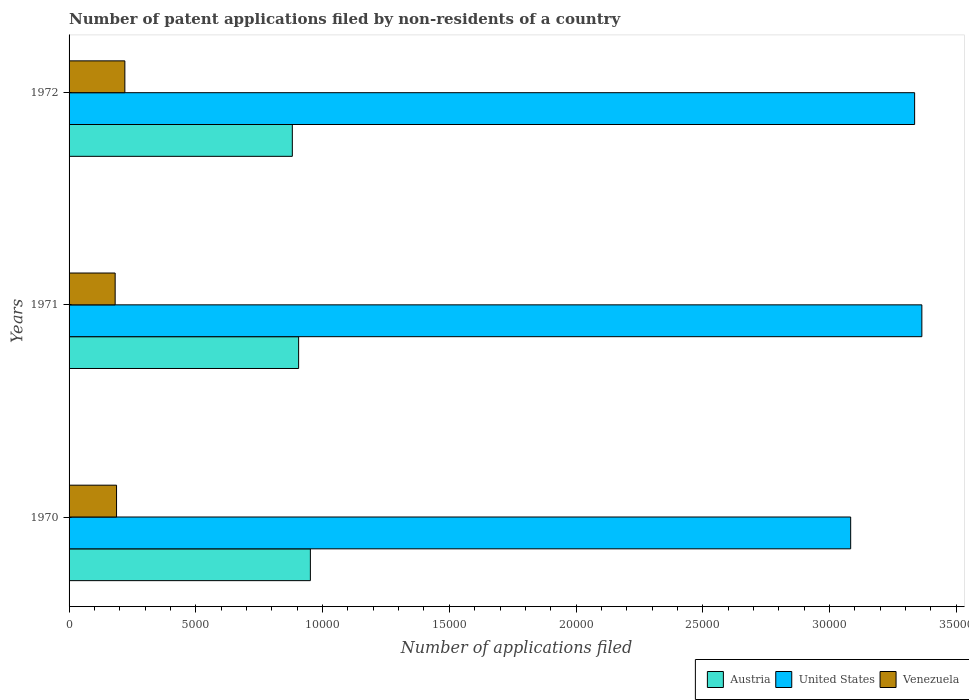How many different coloured bars are there?
Offer a very short reply. 3. How many bars are there on the 2nd tick from the top?
Provide a succinct answer. 3. How many bars are there on the 3rd tick from the bottom?
Make the answer very short. 3. What is the label of the 2nd group of bars from the top?
Make the answer very short. 1971. What is the number of applications filed in Austria in 1970?
Give a very brief answer. 9519. Across all years, what is the maximum number of applications filed in Venezuela?
Offer a terse response. 2201. Across all years, what is the minimum number of applications filed in Austria?
Offer a terse response. 8807. What is the total number of applications filed in Austria in the graph?
Offer a terse response. 2.74e+04. What is the difference between the number of applications filed in Austria in 1970 and that in 1972?
Offer a terse response. 712. What is the difference between the number of applications filed in United States in 1970 and the number of applications filed in Venezuela in 1971?
Make the answer very short. 2.90e+04. What is the average number of applications filed in Venezuela per year?
Your answer should be very brief. 1964. In the year 1971, what is the difference between the number of applications filed in Austria and number of applications filed in United States?
Make the answer very short. -2.46e+04. In how many years, is the number of applications filed in United States greater than 4000 ?
Provide a short and direct response. 3. What is the ratio of the number of applications filed in United States in 1971 to that in 1972?
Your response must be concise. 1.01. Is the number of applications filed in United States in 1971 less than that in 1972?
Offer a very short reply. No. Is the difference between the number of applications filed in Austria in 1970 and 1972 greater than the difference between the number of applications filed in United States in 1970 and 1972?
Provide a short and direct response. Yes. What is the difference between the highest and the second highest number of applications filed in Austria?
Your answer should be compact. 464. What is the difference between the highest and the lowest number of applications filed in Austria?
Offer a terse response. 712. What does the 2nd bar from the top in 1972 represents?
Your response must be concise. United States. What does the 3rd bar from the bottom in 1971 represents?
Provide a succinct answer. Venezuela. Is it the case that in every year, the sum of the number of applications filed in United States and number of applications filed in Austria is greater than the number of applications filed in Venezuela?
Offer a terse response. Yes. How many years are there in the graph?
Your answer should be compact. 3. Are the values on the major ticks of X-axis written in scientific E-notation?
Keep it short and to the point. No. How are the legend labels stacked?
Provide a succinct answer. Horizontal. What is the title of the graph?
Offer a terse response. Number of patent applications filed by non-residents of a country. Does "Malaysia" appear as one of the legend labels in the graph?
Provide a short and direct response. No. What is the label or title of the X-axis?
Ensure brevity in your answer.  Number of applications filed. What is the label or title of the Y-axis?
Your answer should be compact. Years. What is the Number of applications filed of Austria in 1970?
Offer a terse response. 9519. What is the Number of applications filed of United States in 1970?
Your answer should be compact. 3.08e+04. What is the Number of applications filed in Venezuela in 1970?
Your answer should be compact. 1873. What is the Number of applications filed of Austria in 1971?
Keep it short and to the point. 9055. What is the Number of applications filed of United States in 1971?
Your response must be concise. 3.36e+04. What is the Number of applications filed in Venezuela in 1971?
Your response must be concise. 1818. What is the Number of applications filed in Austria in 1972?
Keep it short and to the point. 8807. What is the Number of applications filed in United States in 1972?
Provide a succinct answer. 3.34e+04. What is the Number of applications filed of Venezuela in 1972?
Your answer should be very brief. 2201. Across all years, what is the maximum Number of applications filed in Austria?
Give a very brief answer. 9519. Across all years, what is the maximum Number of applications filed in United States?
Offer a very short reply. 3.36e+04. Across all years, what is the maximum Number of applications filed in Venezuela?
Provide a succinct answer. 2201. Across all years, what is the minimum Number of applications filed of Austria?
Offer a terse response. 8807. Across all years, what is the minimum Number of applications filed of United States?
Provide a short and direct response. 3.08e+04. Across all years, what is the minimum Number of applications filed in Venezuela?
Provide a succinct answer. 1818. What is the total Number of applications filed of Austria in the graph?
Your response must be concise. 2.74e+04. What is the total Number of applications filed of United States in the graph?
Keep it short and to the point. 9.78e+04. What is the total Number of applications filed in Venezuela in the graph?
Give a very brief answer. 5892. What is the difference between the Number of applications filed of Austria in 1970 and that in 1971?
Ensure brevity in your answer.  464. What is the difference between the Number of applications filed of United States in 1970 and that in 1971?
Ensure brevity in your answer.  -2808. What is the difference between the Number of applications filed in Venezuela in 1970 and that in 1971?
Your response must be concise. 55. What is the difference between the Number of applications filed in Austria in 1970 and that in 1972?
Provide a short and direct response. 712. What is the difference between the Number of applications filed in United States in 1970 and that in 1972?
Keep it short and to the point. -2523. What is the difference between the Number of applications filed of Venezuela in 1970 and that in 1972?
Your response must be concise. -328. What is the difference between the Number of applications filed in Austria in 1971 and that in 1972?
Your answer should be compact. 248. What is the difference between the Number of applications filed in United States in 1971 and that in 1972?
Provide a short and direct response. 285. What is the difference between the Number of applications filed in Venezuela in 1971 and that in 1972?
Give a very brief answer. -383. What is the difference between the Number of applications filed of Austria in 1970 and the Number of applications filed of United States in 1971?
Provide a short and direct response. -2.41e+04. What is the difference between the Number of applications filed in Austria in 1970 and the Number of applications filed in Venezuela in 1971?
Your answer should be very brief. 7701. What is the difference between the Number of applications filed in United States in 1970 and the Number of applications filed in Venezuela in 1971?
Your answer should be compact. 2.90e+04. What is the difference between the Number of applications filed of Austria in 1970 and the Number of applications filed of United States in 1972?
Provide a succinct answer. -2.38e+04. What is the difference between the Number of applications filed in Austria in 1970 and the Number of applications filed in Venezuela in 1972?
Ensure brevity in your answer.  7318. What is the difference between the Number of applications filed in United States in 1970 and the Number of applications filed in Venezuela in 1972?
Give a very brief answer. 2.86e+04. What is the difference between the Number of applications filed of Austria in 1971 and the Number of applications filed of United States in 1972?
Your answer should be compact. -2.43e+04. What is the difference between the Number of applications filed in Austria in 1971 and the Number of applications filed in Venezuela in 1972?
Ensure brevity in your answer.  6854. What is the difference between the Number of applications filed of United States in 1971 and the Number of applications filed of Venezuela in 1972?
Offer a very short reply. 3.14e+04. What is the average Number of applications filed of Austria per year?
Your answer should be very brief. 9127. What is the average Number of applications filed in United States per year?
Your response must be concise. 3.26e+04. What is the average Number of applications filed in Venezuela per year?
Offer a very short reply. 1964. In the year 1970, what is the difference between the Number of applications filed in Austria and Number of applications filed in United States?
Ensure brevity in your answer.  -2.13e+04. In the year 1970, what is the difference between the Number of applications filed in Austria and Number of applications filed in Venezuela?
Ensure brevity in your answer.  7646. In the year 1970, what is the difference between the Number of applications filed in United States and Number of applications filed in Venezuela?
Keep it short and to the point. 2.90e+04. In the year 1971, what is the difference between the Number of applications filed of Austria and Number of applications filed of United States?
Offer a terse response. -2.46e+04. In the year 1971, what is the difference between the Number of applications filed of Austria and Number of applications filed of Venezuela?
Make the answer very short. 7237. In the year 1971, what is the difference between the Number of applications filed of United States and Number of applications filed of Venezuela?
Provide a short and direct response. 3.18e+04. In the year 1972, what is the difference between the Number of applications filed of Austria and Number of applications filed of United States?
Your answer should be very brief. -2.45e+04. In the year 1972, what is the difference between the Number of applications filed of Austria and Number of applications filed of Venezuela?
Your response must be concise. 6606. In the year 1972, what is the difference between the Number of applications filed of United States and Number of applications filed of Venezuela?
Keep it short and to the point. 3.12e+04. What is the ratio of the Number of applications filed in Austria in 1970 to that in 1971?
Offer a terse response. 1.05. What is the ratio of the Number of applications filed in United States in 1970 to that in 1971?
Keep it short and to the point. 0.92. What is the ratio of the Number of applications filed of Venezuela in 1970 to that in 1971?
Make the answer very short. 1.03. What is the ratio of the Number of applications filed in Austria in 1970 to that in 1972?
Your answer should be compact. 1.08. What is the ratio of the Number of applications filed in United States in 1970 to that in 1972?
Ensure brevity in your answer.  0.92. What is the ratio of the Number of applications filed in Venezuela in 1970 to that in 1972?
Offer a terse response. 0.85. What is the ratio of the Number of applications filed of Austria in 1971 to that in 1972?
Give a very brief answer. 1.03. What is the ratio of the Number of applications filed in United States in 1971 to that in 1972?
Your answer should be compact. 1.01. What is the ratio of the Number of applications filed in Venezuela in 1971 to that in 1972?
Provide a succinct answer. 0.83. What is the difference between the highest and the second highest Number of applications filed of Austria?
Provide a short and direct response. 464. What is the difference between the highest and the second highest Number of applications filed in United States?
Provide a succinct answer. 285. What is the difference between the highest and the second highest Number of applications filed in Venezuela?
Keep it short and to the point. 328. What is the difference between the highest and the lowest Number of applications filed of Austria?
Make the answer very short. 712. What is the difference between the highest and the lowest Number of applications filed in United States?
Offer a terse response. 2808. What is the difference between the highest and the lowest Number of applications filed in Venezuela?
Provide a succinct answer. 383. 